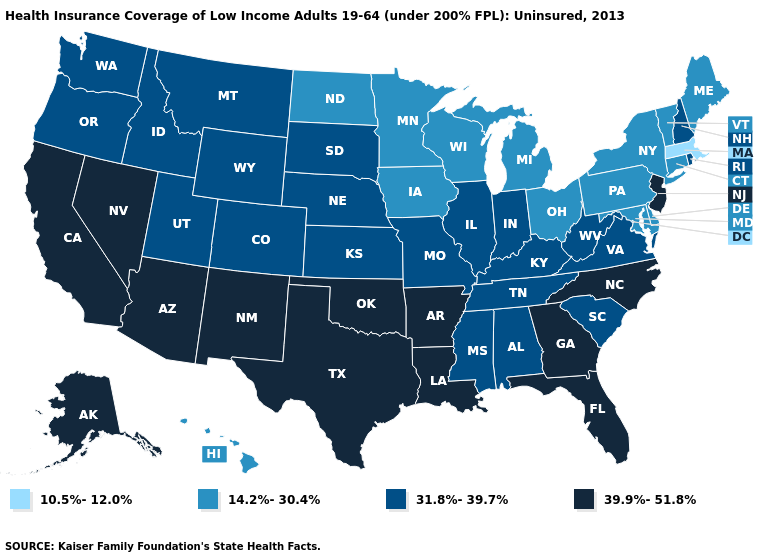Name the states that have a value in the range 39.9%-51.8%?
Concise answer only. Alaska, Arizona, Arkansas, California, Florida, Georgia, Louisiana, Nevada, New Jersey, New Mexico, North Carolina, Oklahoma, Texas. Does Montana have the highest value in the West?
Short answer required. No. What is the lowest value in the Northeast?
Concise answer only. 10.5%-12.0%. Name the states that have a value in the range 10.5%-12.0%?
Be succinct. Massachusetts. What is the value of Minnesota?
Quick response, please. 14.2%-30.4%. Name the states that have a value in the range 14.2%-30.4%?
Keep it brief. Connecticut, Delaware, Hawaii, Iowa, Maine, Maryland, Michigan, Minnesota, New York, North Dakota, Ohio, Pennsylvania, Vermont, Wisconsin. What is the value of Kentucky?
Concise answer only. 31.8%-39.7%. Does Wisconsin have the highest value in the MidWest?
Answer briefly. No. What is the value of North Carolina?
Be succinct. 39.9%-51.8%. What is the value of Wyoming?
Keep it brief. 31.8%-39.7%. What is the value of North Dakota?
Keep it brief. 14.2%-30.4%. Does Washington have the same value as Arizona?
Quick response, please. No. What is the value of Utah?
Concise answer only. 31.8%-39.7%. Which states have the lowest value in the West?
Answer briefly. Hawaii. How many symbols are there in the legend?
Give a very brief answer. 4. 